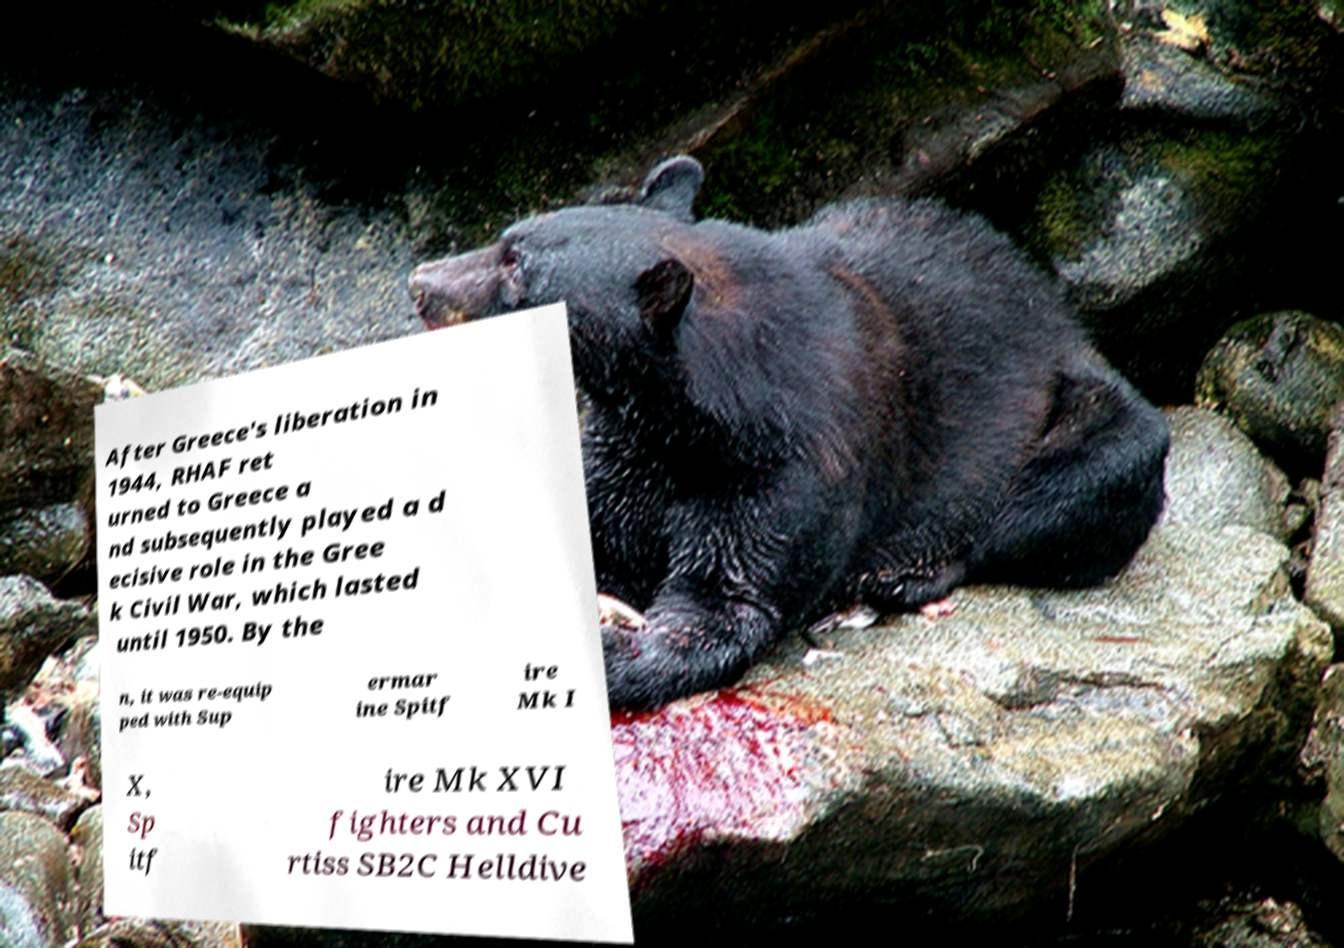Please read and relay the text visible in this image. What does it say? After Greece's liberation in 1944, RHAF ret urned to Greece a nd subsequently played a d ecisive role in the Gree k Civil War, which lasted until 1950. By the n, it was re-equip ped with Sup ermar ine Spitf ire Mk I X, Sp itf ire Mk XVI fighters and Cu rtiss SB2C Helldive 